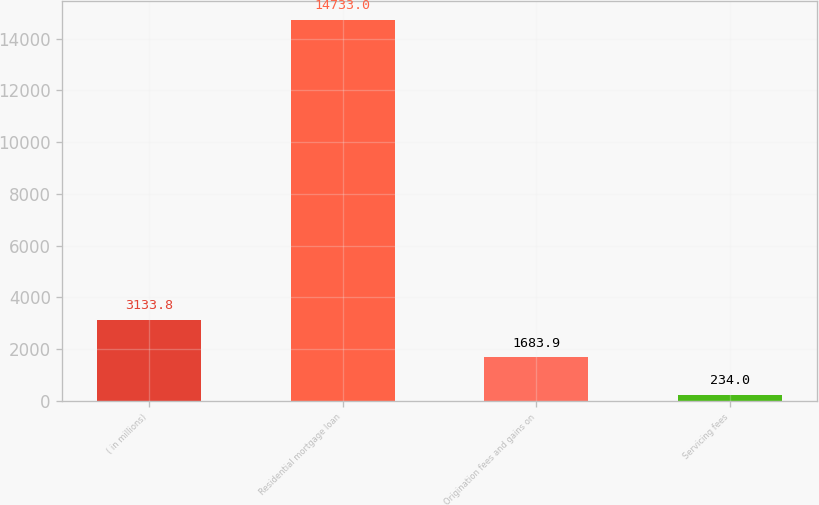<chart> <loc_0><loc_0><loc_500><loc_500><bar_chart><fcel>( in millions)<fcel>Residential mortgage loan<fcel>Origination fees and gains on<fcel>Servicing fees<nl><fcel>3133.8<fcel>14733<fcel>1683.9<fcel>234<nl></chart> 